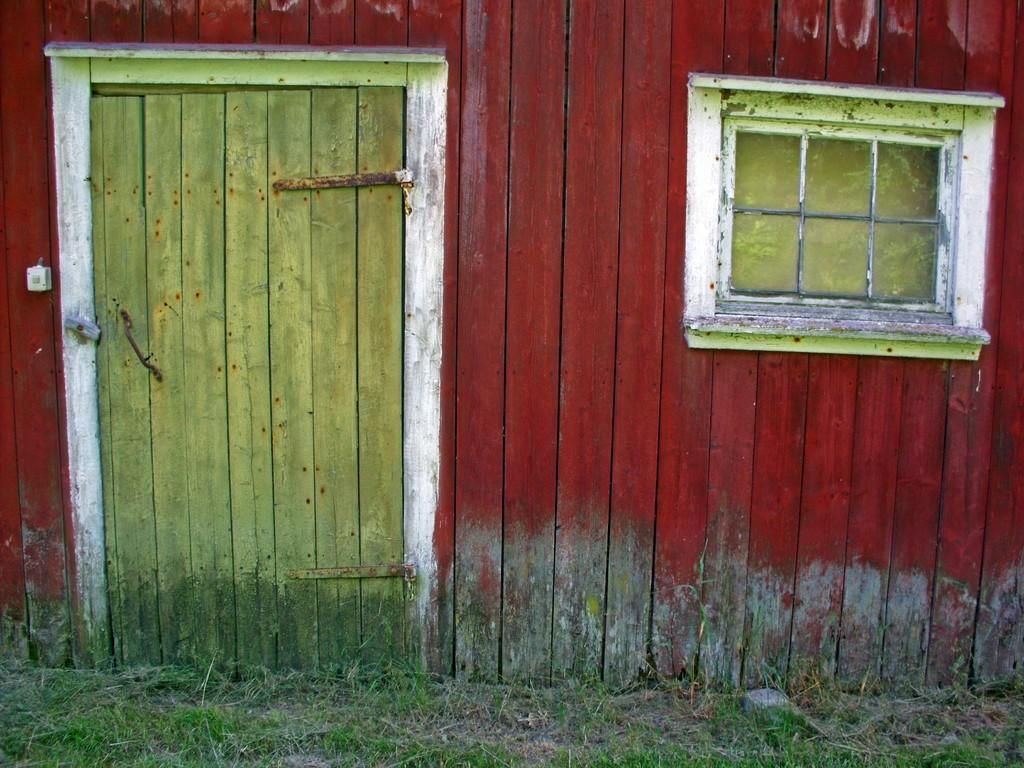What material is the house made of? The house is made of wood. Where is the door located on the house? There is a wooden door on the left side of the house. What type of window is on the right side of the house? There is a glass window on the right side of the house. What type of cannon is placed on the sofa in the image? There is no cannon or sofa present in the image. 